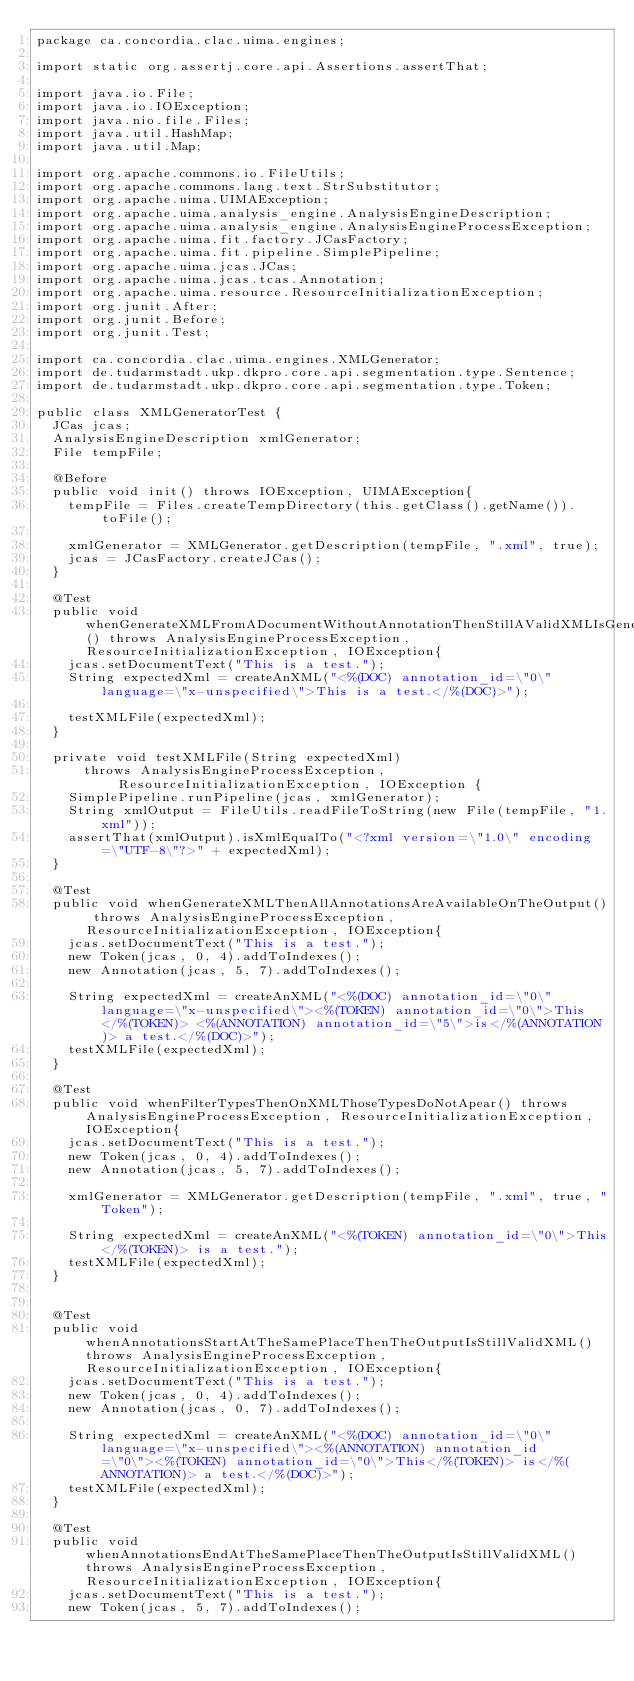<code> <loc_0><loc_0><loc_500><loc_500><_Java_>package ca.concordia.clac.uima.engines;

import static org.assertj.core.api.Assertions.assertThat;

import java.io.File;
import java.io.IOException;
import java.nio.file.Files;
import java.util.HashMap;
import java.util.Map;

import org.apache.commons.io.FileUtils;
import org.apache.commons.lang.text.StrSubstitutor;
import org.apache.uima.UIMAException;
import org.apache.uima.analysis_engine.AnalysisEngineDescription;
import org.apache.uima.analysis_engine.AnalysisEngineProcessException;
import org.apache.uima.fit.factory.JCasFactory;
import org.apache.uima.fit.pipeline.SimplePipeline;
import org.apache.uima.jcas.JCas;
import org.apache.uima.jcas.tcas.Annotation;
import org.apache.uima.resource.ResourceInitializationException;
import org.junit.After;
import org.junit.Before;
import org.junit.Test;

import ca.concordia.clac.uima.engines.XMLGenerator;
import de.tudarmstadt.ukp.dkpro.core.api.segmentation.type.Sentence;
import de.tudarmstadt.ukp.dkpro.core.api.segmentation.type.Token;

public class XMLGeneratorTest {
	JCas jcas;
	AnalysisEngineDescription xmlGenerator;
	File tempFile;
	
	@Before
	public void init() throws IOException, UIMAException{
		tempFile = Files.createTempDirectory(this.getClass().getName()).toFile();
		
		xmlGenerator = XMLGenerator.getDescription(tempFile, ".xml", true);
		jcas = JCasFactory.createJCas();
	}

	@Test
	public void whenGenerateXMLFromADocumentWithoutAnnotationThenStillAValidXMLIsGenerated() throws AnalysisEngineProcessException, ResourceInitializationException, IOException{
		jcas.setDocumentText("This is a test.");
		String expectedXml = createAnXML("<%(DOC) annotation_id=\"0\" language=\"x-unspecified\">This is a test.</%(DOC)>");
		
		testXMLFile(expectedXml);
	}

	private void testXMLFile(String expectedXml)
			throws AnalysisEngineProcessException, ResourceInitializationException, IOException {
		SimplePipeline.runPipeline(jcas, xmlGenerator);
		String xmlOutput = FileUtils.readFileToString(new File(tempFile, "1.xml"));
		assertThat(xmlOutput).isXmlEqualTo("<?xml version=\"1.0\" encoding=\"UTF-8\"?>" + expectedXml);
	}
	
	@Test
	public void whenGenerateXMLThenAllAnnotationsAreAvailableOnTheOutput() throws AnalysisEngineProcessException, ResourceInitializationException, IOException{
		jcas.setDocumentText("This is a test.");
		new Token(jcas, 0, 4).addToIndexes();
		new Annotation(jcas, 5, 7).addToIndexes();
		
		String expectedXml = createAnXML("<%(DOC) annotation_id=\"0\" language=\"x-unspecified\"><%(TOKEN) annotation_id=\"0\">This</%(TOKEN)> <%(ANNOTATION) annotation_id=\"5\">is</%(ANNOTATION)> a test.</%(DOC)>");
		testXMLFile(expectedXml);
	}
	
	@Test
	public void whenFilterTypesThenOnXMLThoseTypesDoNotApear() throws AnalysisEngineProcessException, ResourceInitializationException, IOException{
		jcas.setDocumentText("This is a test.");
		new Token(jcas, 0, 4).addToIndexes();
		new Annotation(jcas, 5, 7).addToIndexes();
		
		xmlGenerator = XMLGenerator.getDescription(tempFile, ".xml", true, "Token");
		
		String expectedXml = createAnXML("<%(TOKEN) annotation_id=\"0\">This</%(TOKEN)> is a test.");
		testXMLFile(expectedXml);
	}

	
	@Test
	public void whenAnnotationsStartAtTheSamePlaceThenTheOutputIsStillValidXML() throws AnalysisEngineProcessException, ResourceInitializationException, IOException{
		jcas.setDocumentText("This is a test.");
		new Token(jcas, 0, 4).addToIndexes();
		new Annotation(jcas, 0, 7).addToIndexes();
		
		String expectedXml = createAnXML("<%(DOC) annotation_id=\"0\" language=\"x-unspecified\"><%(ANNOTATION) annotation_id=\"0\"><%(TOKEN) annotation_id=\"0\">This</%(TOKEN)> is</%(ANNOTATION)> a test.</%(DOC)>");
		testXMLFile(expectedXml);
	}

	@Test
	public void whenAnnotationsEndAtTheSamePlaceThenTheOutputIsStillValidXML() throws AnalysisEngineProcessException, ResourceInitializationException, IOException{
		jcas.setDocumentText("This is a test.");
		new Token(jcas, 5, 7).addToIndexes();</code> 